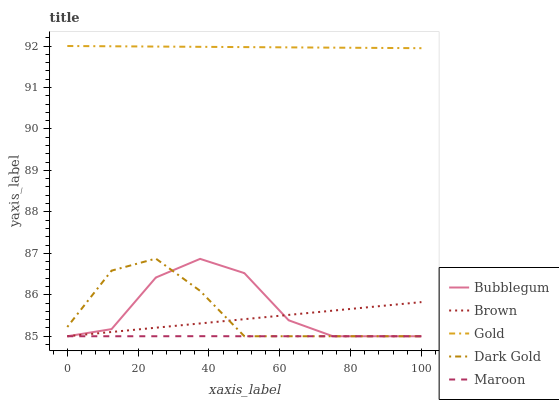Does Maroon have the minimum area under the curve?
Answer yes or no. Yes. Does Gold have the maximum area under the curve?
Answer yes or no. Yes. Does Brown have the minimum area under the curve?
Answer yes or no. No. Does Brown have the maximum area under the curve?
Answer yes or no. No. Is Gold the smoothest?
Answer yes or no. Yes. Is Bubblegum the roughest?
Answer yes or no. Yes. Is Brown the smoothest?
Answer yes or no. No. Is Brown the roughest?
Answer yes or no. No. Does Maroon have the lowest value?
Answer yes or no. Yes. Does Gold have the lowest value?
Answer yes or no. No. Does Gold have the highest value?
Answer yes or no. Yes. Does Brown have the highest value?
Answer yes or no. No. Is Dark Gold less than Gold?
Answer yes or no. Yes. Is Gold greater than Brown?
Answer yes or no. Yes. Does Maroon intersect Brown?
Answer yes or no. Yes. Is Maroon less than Brown?
Answer yes or no. No. Is Maroon greater than Brown?
Answer yes or no. No. Does Dark Gold intersect Gold?
Answer yes or no. No. 